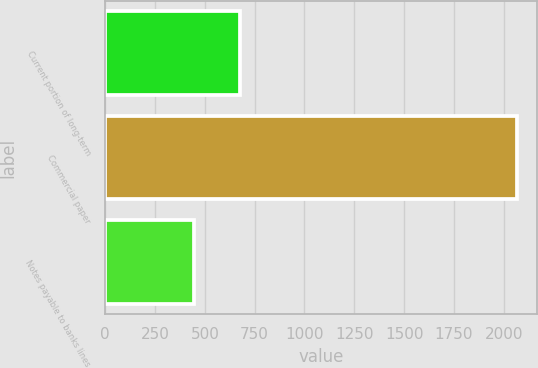Convert chart to OTSL. <chart><loc_0><loc_0><loc_500><loc_500><bar_chart><fcel>Current portion of long-term<fcel>Commercial paper<fcel>Notes payable to banks lines<nl><fcel>675<fcel>2065<fcel>446<nl></chart> 